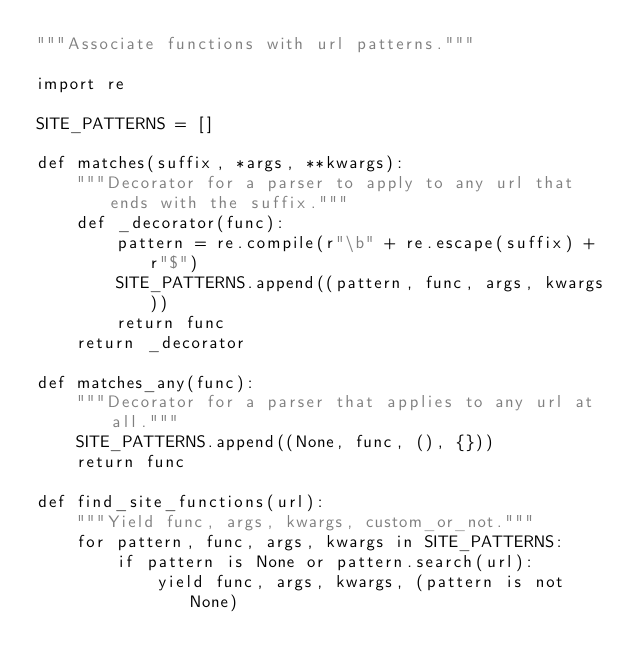<code> <loc_0><loc_0><loc_500><loc_500><_Python_>"""Associate functions with url patterns."""

import re

SITE_PATTERNS = []

def matches(suffix, *args, **kwargs):
    """Decorator for a parser to apply to any url that ends with the suffix."""
    def _decorator(func):
        pattern = re.compile(r"\b" + re.escape(suffix) + r"$")
        SITE_PATTERNS.append((pattern, func, args, kwargs))
        return func
    return _decorator

def matches_any(func):
    """Decorator for a parser that applies to any url at all."""
    SITE_PATTERNS.append((None, func, (), {}))
    return func

def find_site_functions(url):
    """Yield func, args, kwargs, custom_or_not."""
    for pattern, func, args, kwargs in SITE_PATTERNS:
        if pattern is None or pattern.search(url):
            yield func, args, kwargs, (pattern is not None)
</code> 